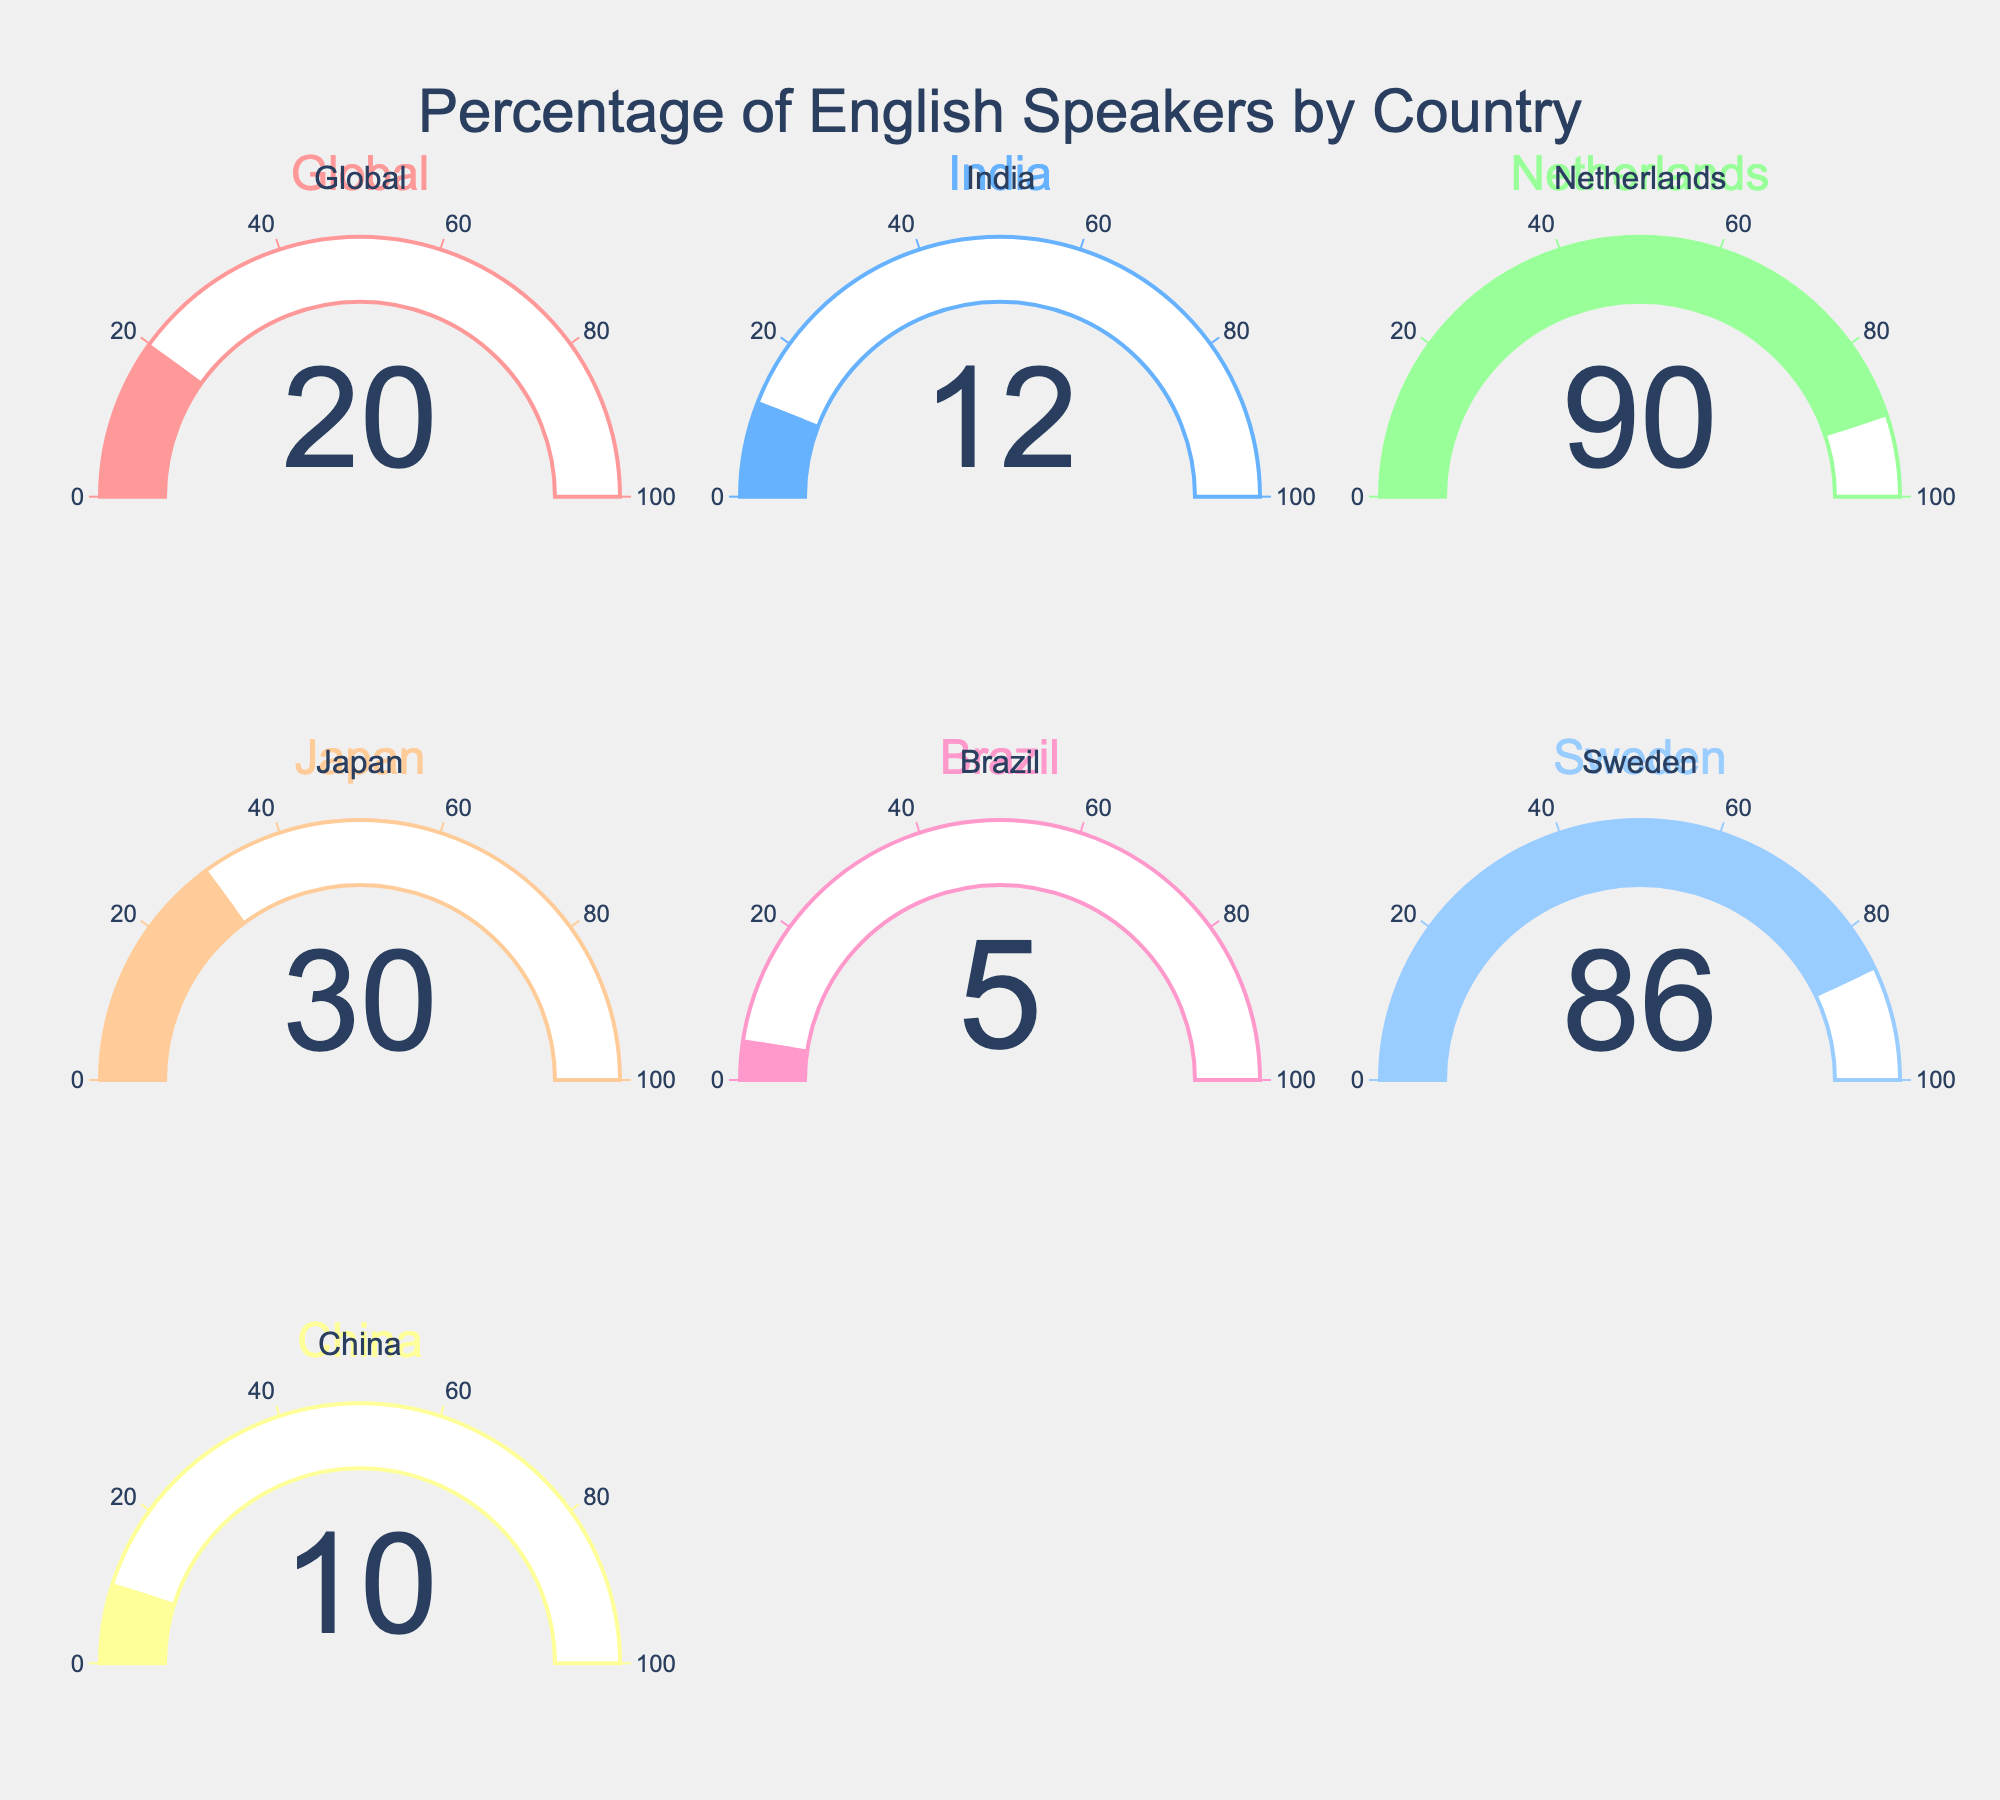Which country has the highest percentage of English speakers? By looking at the gauges, the Netherlands has the highest percentage with a value of 90%.
Answer: Netherlands Which country has the lowest percentage of English speakers? By comparing all the gauges, Brazil has the lowest percentage at 5%.
Answer: Brazil What is the percentage of English speakers in Japan? The gauge labeled "Japan" shows a value of 30%.
Answer: 30% What is the average percentage of English speakers in India, China, and Brazil? The percentages are 12%, 10%, and 5% respectively. Adding them gives 27. Dividing by 3 gives an average of 27/3 = 9%.
Answer: 9% How does the percentage of English speakers in India compare to China? India has 12% and China has 10%. 12% is greater than 10%.
Answer: India has a higher percentage What is the sum of the percentages of English speakers in Sweden and the Netherlands? Sweden has 86% and the Netherlands has 90%. Summing these values gives 86 + 90 = 176%.
Answer: 176% Which two countries have an equal percentage of English speakers? By comparing all the gauges, no two countries have the same percentage of English speakers.
Answer: None What is the difference in the percentage of English speakers between Japan and Brazil? Japan has 30% and Brazil has 5%. The difference is 30 - 5 = 25%.
Answer: 25% Which country has a higher percentage of English speakers: Sweden or India? Sweden has 86% and India has 12%, so Sweden has a higher percentage.
Answer: Sweden If the global percentage is 20%, which countries have a percentage above this number? By comparing the gauges, Japan (30%), Netherlands (90%), and Sweden (86%) have percentages above the global average of 20%.
Answer: Japan, Netherlands, Sweden 